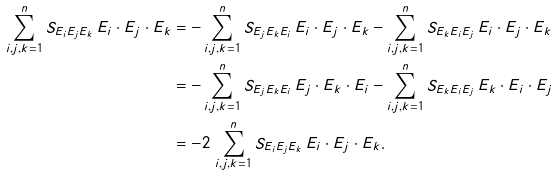<formula> <loc_0><loc_0><loc_500><loc_500>\sum _ { i , j , k = 1 } ^ { n } S _ { E _ { i } E _ { j } E _ { k } } \, E _ { i } \cdot E _ { j } \cdot E _ { k } & = - \sum _ { i , j , k = 1 } ^ { n } S _ { E _ { j } E _ { k } E _ { i } } \, E _ { i } \cdot E _ { j } \cdot E _ { k } - \sum _ { i , j , k = 1 } ^ { n } S _ { E _ { k } E _ { i } E _ { j } } \, E _ { i } \cdot E _ { j } \cdot E _ { k } \\ & = - \sum _ { i , j , k = 1 } ^ { n } S _ { E _ { j } E _ { k } E _ { i } } \, E _ { j } \cdot E _ { k } \cdot E _ { i } - \sum _ { i , j , k = 1 } ^ { n } S _ { E _ { k } E _ { i } E _ { j } } \, E _ { k } \cdot E _ { i } \cdot E _ { j } \\ & = - 2 \, \sum _ { i , j , k = 1 } ^ { n } S _ { E _ { i } E _ { j } E _ { k } } \, E _ { i } \cdot E _ { j } \cdot E _ { k } .</formula> 